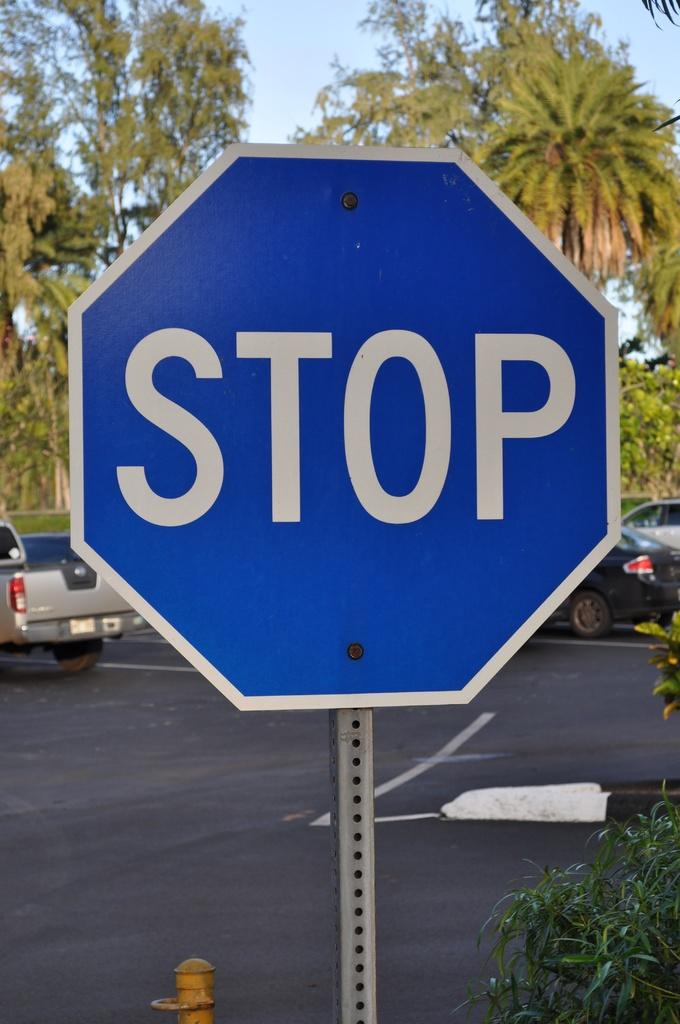<image>
Write a terse but informative summary of the picture. A close view of a stop sign that is blue instead or red. 